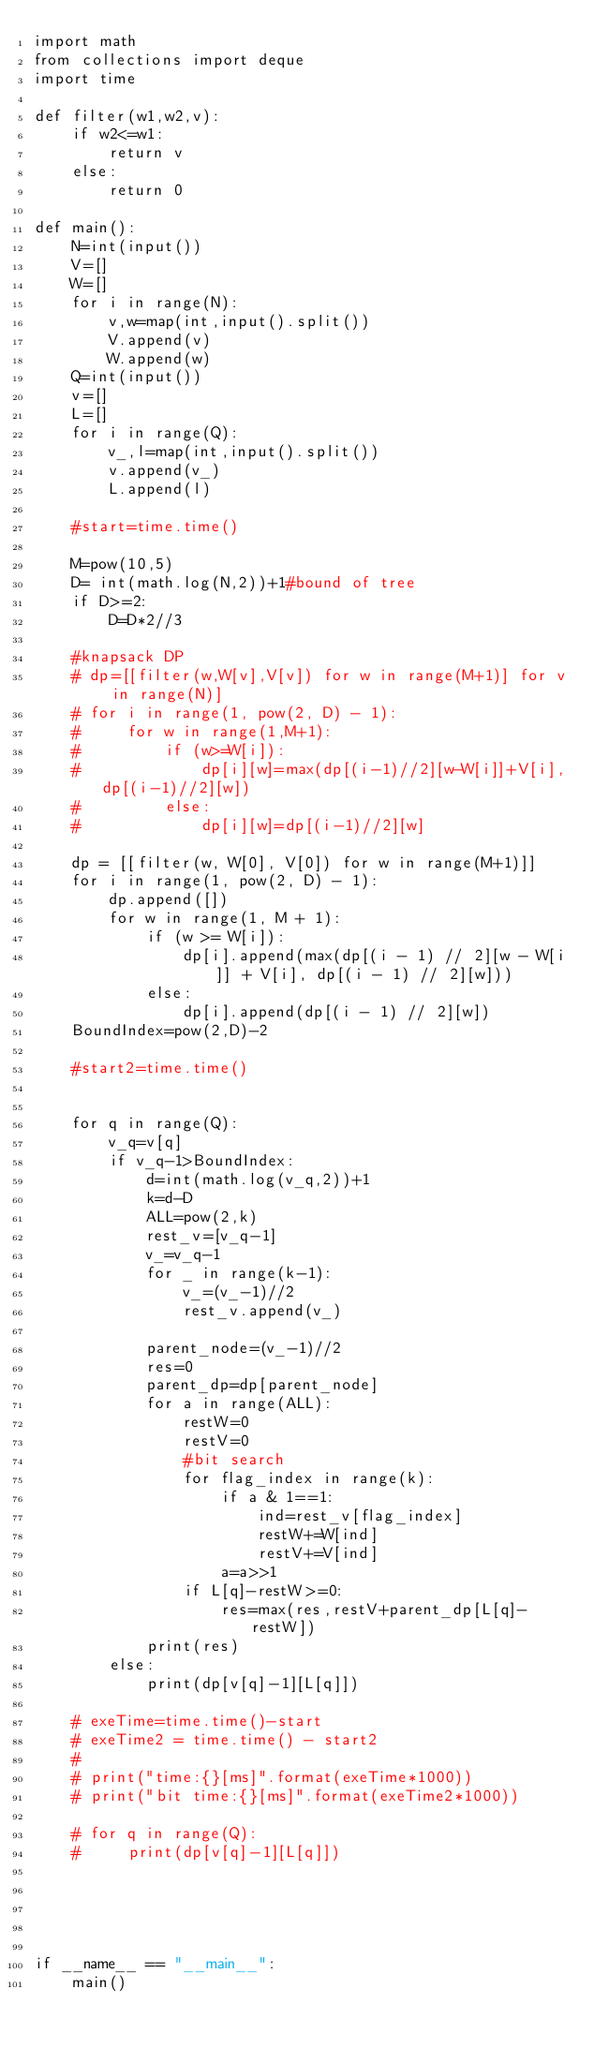<code> <loc_0><loc_0><loc_500><loc_500><_Python_>import math
from collections import deque
import time

def filter(w1,w2,v):
    if w2<=w1:
        return v
    else:
        return 0

def main():
    N=int(input())
    V=[]
    W=[]
    for i in range(N):
        v,w=map(int,input().split())
        V.append(v)
        W.append(w)
    Q=int(input())
    v=[]
    L=[]
    for i in range(Q):
        v_,l=map(int,input().split())
        v.append(v_)
        L.append(l)

    #start=time.time()

    M=pow(10,5)
    D= int(math.log(N,2))+1#bound of tree
    if D>=2:
        D=D*2//3

    #knapsack DP
    # dp=[[filter(w,W[v],V[v]) for w in range(M+1)] for v in range(N)]
    # for i in range(1, pow(2, D) - 1):
    #     for w in range(1,M+1):
    #         if (w>=W[i]):
    #             dp[i][w]=max(dp[(i-1)//2][w-W[i]]+V[i],dp[(i-1)//2][w])
    #         else:
    #             dp[i][w]=dp[(i-1)//2][w]

    dp = [[filter(w, W[0], V[0]) for w in range(M+1)]]
    for i in range(1, pow(2, D) - 1):
        dp.append([])
        for w in range(1, M + 1):
            if (w >= W[i]):
                dp[i].append(max(dp[(i - 1) // 2][w - W[i]] + V[i], dp[(i - 1) // 2][w]))
            else:
                dp[i].append(dp[(i - 1) // 2][w])
    BoundIndex=pow(2,D)-2

    #start2=time.time()


    for q in range(Q):
        v_q=v[q]
        if v_q-1>BoundIndex:
            d=int(math.log(v_q,2))+1
            k=d-D
            ALL=pow(2,k)
            rest_v=[v_q-1]
            v_=v_q-1
            for _ in range(k-1):
                v_=(v_-1)//2
                rest_v.append(v_)

            parent_node=(v_-1)//2
            res=0
            parent_dp=dp[parent_node]
            for a in range(ALL):
                restW=0
                restV=0
                #bit search
                for flag_index in range(k):
                    if a & 1==1:
                        ind=rest_v[flag_index]
                        restW+=W[ind]
                        restV+=V[ind]
                    a=a>>1
                if L[q]-restW>=0:
                    res=max(res,restV+parent_dp[L[q]-restW])
            print(res)
        else:
            print(dp[v[q]-1][L[q]])

    # exeTime=time.time()-start
    # exeTime2 = time.time() - start2
    #
    # print("time:{}[ms]".format(exeTime*1000))
    # print("bit time:{}[ms]".format(exeTime2*1000))

    # for q in range(Q):
    #     print(dp[v[q]-1][L[q]])





if __name__ == "__main__":
    main()
</code> 